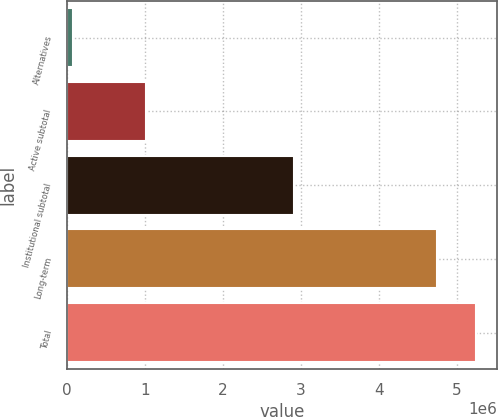Convert chart. <chart><loc_0><loc_0><loc_500><loc_500><bar_chart><fcel>Alternatives<fcel>Active subtotal<fcel>Institutional subtotal<fcel>Long-term<fcel>Total<nl><fcel>75615<fcel>1.00997e+06<fcel>2.91166e+06<fcel>4.74149e+06<fcel>5.24871e+06<nl></chart> 